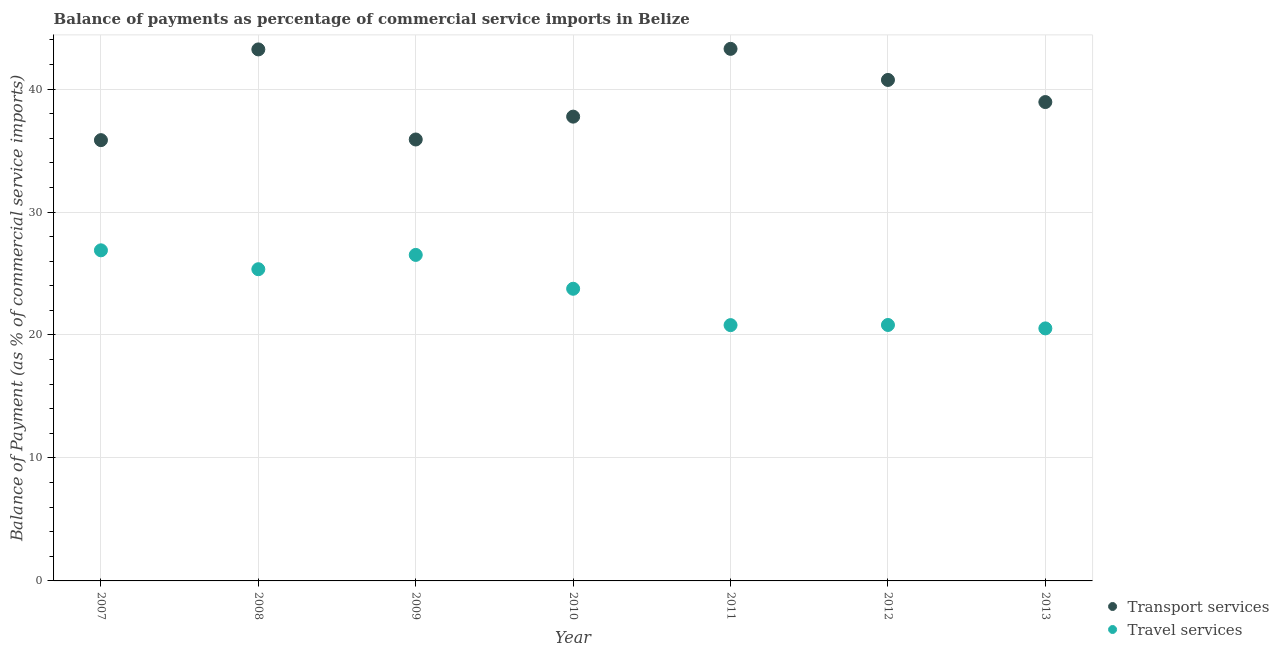Is the number of dotlines equal to the number of legend labels?
Your answer should be very brief. Yes. What is the balance of payments of travel services in 2011?
Make the answer very short. 20.8. Across all years, what is the maximum balance of payments of transport services?
Provide a short and direct response. 43.27. Across all years, what is the minimum balance of payments of transport services?
Make the answer very short. 35.85. In which year was the balance of payments of travel services maximum?
Your answer should be very brief. 2007. In which year was the balance of payments of transport services minimum?
Your answer should be very brief. 2007. What is the total balance of payments of transport services in the graph?
Provide a short and direct response. 275.69. What is the difference between the balance of payments of transport services in 2009 and that in 2013?
Your response must be concise. -3.04. What is the difference between the balance of payments of transport services in 2010 and the balance of payments of travel services in 2012?
Your answer should be very brief. 16.94. What is the average balance of payments of transport services per year?
Your answer should be compact. 39.38. In the year 2007, what is the difference between the balance of payments of travel services and balance of payments of transport services?
Give a very brief answer. -8.96. What is the ratio of the balance of payments of transport services in 2008 to that in 2011?
Ensure brevity in your answer.  1. Is the difference between the balance of payments of travel services in 2009 and 2011 greater than the difference between the balance of payments of transport services in 2009 and 2011?
Your answer should be very brief. Yes. What is the difference between the highest and the second highest balance of payments of travel services?
Keep it short and to the point. 0.37. What is the difference between the highest and the lowest balance of payments of transport services?
Ensure brevity in your answer.  7.42. Is the balance of payments of transport services strictly less than the balance of payments of travel services over the years?
Your answer should be compact. No. How many dotlines are there?
Your response must be concise. 2. How many years are there in the graph?
Offer a terse response. 7. Does the graph contain any zero values?
Make the answer very short. No. How many legend labels are there?
Make the answer very short. 2. What is the title of the graph?
Provide a short and direct response. Balance of payments as percentage of commercial service imports in Belize. What is the label or title of the X-axis?
Your response must be concise. Year. What is the label or title of the Y-axis?
Ensure brevity in your answer.  Balance of Payment (as % of commercial service imports). What is the Balance of Payment (as % of commercial service imports) in Transport services in 2007?
Your response must be concise. 35.85. What is the Balance of Payment (as % of commercial service imports) in Travel services in 2007?
Provide a succinct answer. 26.89. What is the Balance of Payment (as % of commercial service imports) of Transport services in 2008?
Provide a short and direct response. 43.23. What is the Balance of Payment (as % of commercial service imports) in Travel services in 2008?
Provide a short and direct response. 25.35. What is the Balance of Payment (as % of commercial service imports) in Transport services in 2009?
Offer a terse response. 35.9. What is the Balance of Payment (as % of commercial service imports) in Travel services in 2009?
Provide a short and direct response. 26.51. What is the Balance of Payment (as % of commercial service imports) of Transport services in 2010?
Your answer should be compact. 37.76. What is the Balance of Payment (as % of commercial service imports) in Travel services in 2010?
Keep it short and to the point. 23.76. What is the Balance of Payment (as % of commercial service imports) in Transport services in 2011?
Your answer should be very brief. 43.27. What is the Balance of Payment (as % of commercial service imports) of Travel services in 2011?
Provide a short and direct response. 20.8. What is the Balance of Payment (as % of commercial service imports) of Transport services in 2012?
Keep it short and to the point. 40.74. What is the Balance of Payment (as % of commercial service imports) in Travel services in 2012?
Offer a very short reply. 20.82. What is the Balance of Payment (as % of commercial service imports) of Transport services in 2013?
Provide a short and direct response. 38.94. What is the Balance of Payment (as % of commercial service imports) of Travel services in 2013?
Give a very brief answer. 20.54. Across all years, what is the maximum Balance of Payment (as % of commercial service imports) of Transport services?
Make the answer very short. 43.27. Across all years, what is the maximum Balance of Payment (as % of commercial service imports) of Travel services?
Offer a terse response. 26.89. Across all years, what is the minimum Balance of Payment (as % of commercial service imports) in Transport services?
Your answer should be very brief. 35.85. Across all years, what is the minimum Balance of Payment (as % of commercial service imports) in Travel services?
Ensure brevity in your answer.  20.54. What is the total Balance of Payment (as % of commercial service imports) in Transport services in the graph?
Keep it short and to the point. 275.69. What is the total Balance of Payment (as % of commercial service imports) of Travel services in the graph?
Give a very brief answer. 164.66. What is the difference between the Balance of Payment (as % of commercial service imports) in Transport services in 2007 and that in 2008?
Ensure brevity in your answer.  -7.38. What is the difference between the Balance of Payment (as % of commercial service imports) of Travel services in 2007 and that in 2008?
Provide a succinct answer. 1.54. What is the difference between the Balance of Payment (as % of commercial service imports) in Transport services in 2007 and that in 2009?
Keep it short and to the point. -0.05. What is the difference between the Balance of Payment (as % of commercial service imports) in Travel services in 2007 and that in 2009?
Your response must be concise. 0.37. What is the difference between the Balance of Payment (as % of commercial service imports) of Transport services in 2007 and that in 2010?
Your answer should be compact. -1.91. What is the difference between the Balance of Payment (as % of commercial service imports) of Travel services in 2007 and that in 2010?
Offer a terse response. 3.13. What is the difference between the Balance of Payment (as % of commercial service imports) in Transport services in 2007 and that in 2011?
Ensure brevity in your answer.  -7.42. What is the difference between the Balance of Payment (as % of commercial service imports) of Travel services in 2007 and that in 2011?
Provide a succinct answer. 6.08. What is the difference between the Balance of Payment (as % of commercial service imports) of Transport services in 2007 and that in 2012?
Keep it short and to the point. -4.9. What is the difference between the Balance of Payment (as % of commercial service imports) of Travel services in 2007 and that in 2012?
Your answer should be compact. 6.07. What is the difference between the Balance of Payment (as % of commercial service imports) of Transport services in 2007 and that in 2013?
Provide a short and direct response. -3.1. What is the difference between the Balance of Payment (as % of commercial service imports) of Travel services in 2007 and that in 2013?
Ensure brevity in your answer.  6.35. What is the difference between the Balance of Payment (as % of commercial service imports) of Transport services in 2008 and that in 2009?
Give a very brief answer. 7.33. What is the difference between the Balance of Payment (as % of commercial service imports) of Travel services in 2008 and that in 2009?
Give a very brief answer. -1.16. What is the difference between the Balance of Payment (as % of commercial service imports) in Transport services in 2008 and that in 2010?
Give a very brief answer. 5.47. What is the difference between the Balance of Payment (as % of commercial service imports) in Travel services in 2008 and that in 2010?
Provide a succinct answer. 1.59. What is the difference between the Balance of Payment (as % of commercial service imports) in Transport services in 2008 and that in 2011?
Provide a short and direct response. -0.05. What is the difference between the Balance of Payment (as % of commercial service imports) in Travel services in 2008 and that in 2011?
Make the answer very short. 4.55. What is the difference between the Balance of Payment (as % of commercial service imports) in Transport services in 2008 and that in 2012?
Provide a succinct answer. 2.48. What is the difference between the Balance of Payment (as % of commercial service imports) in Travel services in 2008 and that in 2012?
Provide a succinct answer. 4.53. What is the difference between the Balance of Payment (as % of commercial service imports) in Transport services in 2008 and that in 2013?
Provide a short and direct response. 4.28. What is the difference between the Balance of Payment (as % of commercial service imports) of Travel services in 2008 and that in 2013?
Your response must be concise. 4.81. What is the difference between the Balance of Payment (as % of commercial service imports) of Transport services in 2009 and that in 2010?
Your answer should be compact. -1.86. What is the difference between the Balance of Payment (as % of commercial service imports) of Travel services in 2009 and that in 2010?
Your answer should be compact. 2.75. What is the difference between the Balance of Payment (as % of commercial service imports) in Transport services in 2009 and that in 2011?
Your response must be concise. -7.37. What is the difference between the Balance of Payment (as % of commercial service imports) in Travel services in 2009 and that in 2011?
Your response must be concise. 5.71. What is the difference between the Balance of Payment (as % of commercial service imports) of Transport services in 2009 and that in 2012?
Offer a very short reply. -4.84. What is the difference between the Balance of Payment (as % of commercial service imports) in Travel services in 2009 and that in 2012?
Provide a succinct answer. 5.7. What is the difference between the Balance of Payment (as % of commercial service imports) of Transport services in 2009 and that in 2013?
Make the answer very short. -3.04. What is the difference between the Balance of Payment (as % of commercial service imports) in Travel services in 2009 and that in 2013?
Provide a succinct answer. 5.98. What is the difference between the Balance of Payment (as % of commercial service imports) of Transport services in 2010 and that in 2011?
Offer a terse response. -5.51. What is the difference between the Balance of Payment (as % of commercial service imports) of Travel services in 2010 and that in 2011?
Offer a terse response. 2.96. What is the difference between the Balance of Payment (as % of commercial service imports) in Transport services in 2010 and that in 2012?
Your answer should be very brief. -2.98. What is the difference between the Balance of Payment (as % of commercial service imports) in Travel services in 2010 and that in 2012?
Keep it short and to the point. 2.94. What is the difference between the Balance of Payment (as % of commercial service imports) in Transport services in 2010 and that in 2013?
Provide a short and direct response. -1.19. What is the difference between the Balance of Payment (as % of commercial service imports) of Travel services in 2010 and that in 2013?
Ensure brevity in your answer.  3.22. What is the difference between the Balance of Payment (as % of commercial service imports) in Transport services in 2011 and that in 2012?
Your answer should be compact. 2.53. What is the difference between the Balance of Payment (as % of commercial service imports) in Travel services in 2011 and that in 2012?
Offer a terse response. -0.01. What is the difference between the Balance of Payment (as % of commercial service imports) of Transport services in 2011 and that in 2013?
Make the answer very short. 4.33. What is the difference between the Balance of Payment (as % of commercial service imports) of Travel services in 2011 and that in 2013?
Keep it short and to the point. 0.27. What is the difference between the Balance of Payment (as % of commercial service imports) in Transport services in 2012 and that in 2013?
Your answer should be compact. 1.8. What is the difference between the Balance of Payment (as % of commercial service imports) in Travel services in 2012 and that in 2013?
Offer a terse response. 0.28. What is the difference between the Balance of Payment (as % of commercial service imports) in Transport services in 2007 and the Balance of Payment (as % of commercial service imports) in Travel services in 2008?
Offer a terse response. 10.5. What is the difference between the Balance of Payment (as % of commercial service imports) in Transport services in 2007 and the Balance of Payment (as % of commercial service imports) in Travel services in 2009?
Offer a terse response. 9.33. What is the difference between the Balance of Payment (as % of commercial service imports) in Transport services in 2007 and the Balance of Payment (as % of commercial service imports) in Travel services in 2010?
Give a very brief answer. 12.09. What is the difference between the Balance of Payment (as % of commercial service imports) of Transport services in 2007 and the Balance of Payment (as % of commercial service imports) of Travel services in 2011?
Give a very brief answer. 15.04. What is the difference between the Balance of Payment (as % of commercial service imports) of Transport services in 2007 and the Balance of Payment (as % of commercial service imports) of Travel services in 2012?
Your answer should be very brief. 15.03. What is the difference between the Balance of Payment (as % of commercial service imports) of Transport services in 2007 and the Balance of Payment (as % of commercial service imports) of Travel services in 2013?
Your answer should be compact. 15.31. What is the difference between the Balance of Payment (as % of commercial service imports) in Transport services in 2008 and the Balance of Payment (as % of commercial service imports) in Travel services in 2009?
Your answer should be very brief. 16.71. What is the difference between the Balance of Payment (as % of commercial service imports) in Transport services in 2008 and the Balance of Payment (as % of commercial service imports) in Travel services in 2010?
Ensure brevity in your answer.  19.47. What is the difference between the Balance of Payment (as % of commercial service imports) in Transport services in 2008 and the Balance of Payment (as % of commercial service imports) in Travel services in 2011?
Provide a short and direct response. 22.42. What is the difference between the Balance of Payment (as % of commercial service imports) of Transport services in 2008 and the Balance of Payment (as % of commercial service imports) of Travel services in 2012?
Your answer should be very brief. 22.41. What is the difference between the Balance of Payment (as % of commercial service imports) in Transport services in 2008 and the Balance of Payment (as % of commercial service imports) in Travel services in 2013?
Ensure brevity in your answer.  22.69. What is the difference between the Balance of Payment (as % of commercial service imports) of Transport services in 2009 and the Balance of Payment (as % of commercial service imports) of Travel services in 2010?
Ensure brevity in your answer.  12.14. What is the difference between the Balance of Payment (as % of commercial service imports) in Transport services in 2009 and the Balance of Payment (as % of commercial service imports) in Travel services in 2011?
Offer a terse response. 15.1. What is the difference between the Balance of Payment (as % of commercial service imports) in Transport services in 2009 and the Balance of Payment (as % of commercial service imports) in Travel services in 2012?
Provide a short and direct response. 15.09. What is the difference between the Balance of Payment (as % of commercial service imports) of Transport services in 2009 and the Balance of Payment (as % of commercial service imports) of Travel services in 2013?
Ensure brevity in your answer.  15.36. What is the difference between the Balance of Payment (as % of commercial service imports) in Transport services in 2010 and the Balance of Payment (as % of commercial service imports) in Travel services in 2011?
Make the answer very short. 16.96. What is the difference between the Balance of Payment (as % of commercial service imports) of Transport services in 2010 and the Balance of Payment (as % of commercial service imports) of Travel services in 2012?
Your answer should be compact. 16.94. What is the difference between the Balance of Payment (as % of commercial service imports) of Transport services in 2010 and the Balance of Payment (as % of commercial service imports) of Travel services in 2013?
Provide a succinct answer. 17.22. What is the difference between the Balance of Payment (as % of commercial service imports) of Transport services in 2011 and the Balance of Payment (as % of commercial service imports) of Travel services in 2012?
Offer a very short reply. 22.46. What is the difference between the Balance of Payment (as % of commercial service imports) in Transport services in 2011 and the Balance of Payment (as % of commercial service imports) in Travel services in 2013?
Your response must be concise. 22.73. What is the difference between the Balance of Payment (as % of commercial service imports) in Transport services in 2012 and the Balance of Payment (as % of commercial service imports) in Travel services in 2013?
Offer a terse response. 20.21. What is the average Balance of Payment (as % of commercial service imports) in Transport services per year?
Your answer should be very brief. 39.38. What is the average Balance of Payment (as % of commercial service imports) of Travel services per year?
Offer a very short reply. 23.52. In the year 2007, what is the difference between the Balance of Payment (as % of commercial service imports) in Transport services and Balance of Payment (as % of commercial service imports) in Travel services?
Keep it short and to the point. 8.96. In the year 2008, what is the difference between the Balance of Payment (as % of commercial service imports) in Transport services and Balance of Payment (as % of commercial service imports) in Travel services?
Provide a succinct answer. 17.88. In the year 2009, what is the difference between the Balance of Payment (as % of commercial service imports) in Transport services and Balance of Payment (as % of commercial service imports) in Travel services?
Your answer should be very brief. 9.39. In the year 2010, what is the difference between the Balance of Payment (as % of commercial service imports) of Transport services and Balance of Payment (as % of commercial service imports) of Travel services?
Provide a succinct answer. 14. In the year 2011, what is the difference between the Balance of Payment (as % of commercial service imports) of Transport services and Balance of Payment (as % of commercial service imports) of Travel services?
Provide a succinct answer. 22.47. In the year 2012, what is the difference between the Balance of Payment (as % of commercial service imports) of Transport services and Balance of Payment (as % of commercial service imports) of Travel services?
Provide a short and direct response. 19.93. In the year 2013, what is the difference between the Balance of Payment (as % of commercial service imports) in Transport services and Balance of Payment (as % of commercial service imports) in Travel services?
Your response must be concise. 18.41. What is the ratio of the Balance of Payment (as % of commercial service imports) in Transport services in 2007 to that in 2008?
Provide a succinct answer. 0.83. What is the ratio of the Balance of Payment (as % of commercial service imports) in Travel services in 2007 to that in 2008?
Make the answer very short. 1.06. What is the ratio of the Balance of Payment (as % of commercial service imports) in Transport services in 2007 to that in 2009?
Give a very brief answer. 1. What is the ratio of the Balance of Payment (as % of commercial service imports) of Travel services in 2007 to that in 2009?
Give a very brief answer. 1.01. What is the ratio of the Balance of Payment (as % of commercial service imports) in Transport services in 2007 to that in 2010?
Offer a terse response. 0.95. What is the ratio of the Balance of Payment (as % of commercial service imports) in Travel services in 2007 to that in 2010?
Provide a short and direct response. 1.13. What is the ratio of the Balance of Payment (as % of commercial service imports) of Transport services in 2007 to that in 2011?
Your response must be concise. 0.83. What is the ratio of the Balance of Payment (as % of commercial service imports) of Travel services in 2007 to that in 2011?
Provide a short and direct response. 1.29. What is the ratio of the Balance of Payment (as % of commercial service imports) of Transport services in 2007 to that in 2012?
Your answer should be compact. 0.88. What is the ratio of the Balance of Payment (as % of commercial service imports) in Travel services in 2007 to that in 2012?
Ensure brevity in your answer.  1.29. What is the ratio of the Balance of Payment (as % of commercial service imports) of Transport services in 2007 to that in 2013?
Make the answer very short. 0.92. What is the ratio of the Balance of Payment (as % of commercial service imports) in Travel services in 2007 to that in 2013?
Give a very brief answer. 1.31. What is the ratio of the Balance of Payment (as % of commercial service imports) of Transport services in 2008 to that in 2009?
Your answer should be compact. 1.2. What is the ratio of the Balance of Payment (as % of commercial service imports) in Travel services in 2008 to that in 2009?
Make the answer very short. 0.96. What is the ratio of the Balance of Payment (as % of commercial service imports) in Transport services in 2008 to that in 2010?
Ensure brevity in your answer.  1.14. What is the ratio of the Balance of Payment (as % of commercial service imports) in Travel services in 2008 to that in 2010?
Your answer should be very brief. 1.07. What is the ratio of the Balance of Payment (as % of commercial service imports) in Travel services in 2008 to that in 2011?
Ensure brevity in your answer.  1.22. What is the ratio of the Balance of Payment (as % of commercial service imports) of Transport services in 2008 to that in 2012?
Offer a terse response. 1.06. What is the ratio of the Balance of Payment (as % of commercial service imports) of Travel services in 2008 to that in 2012?
Your answer should be very brief. 1.22. What is the ratio of the Balance of Payment (as % of commercial service imports) in Transport services in 2008 to that in 2013?
Your response must be concise. 1.11. What is the ratio of the Balance of Payment (as % of commercial service imports) in Travel services in 2008 to that in 2013?
Keep it short and to the point. 1.23. What is the ratio of the Balance of Payment (as % of commercial service imports) of Transport services in 2009 to that in 2010?
Your answer should be very brief. 0.95. What is the ratio of the Balance of Payment (as % of commercial service imports) in Travel services in 2009 to that in 2010?
Keep it short and to the point. 1.12. What is the ratio of the Balance of Payment (as % of commercial service imports) in Transport services in 2009 to that in 2011?
Give a very brief answer. 0.83. What is the ratio of the Balance of Payment (as % of commercial service imports) of Travel services in 2009 to that in 2011?
Give a very brief answer. 1.27. What is the ratio of the Balance of Payment (as % of commercial service imports) of Transport services in 2009 to that in 2012?
Make the answer very short. 0.88. What is the ratio of the Balance of Payment (as % of commercial service imports) of Travel services in 2009 to that in 2012?
Ensure brevity in your answer.  1.27. What is the ratio of the Balance of Payment (as % of commercial service imports) in Transport services in 2009 to that in 2013?
Offer a very short reply. 0.92. What is the ratio of the Balance of Payment (as % of commercial service imports) of Travel services in 2009 to that in 2013?
Provide a succinct answer. 1.29. What is the ratio of the Balance of Payment (as % of commercial service imports) in Transport services in 2010 to that in 2011?
Provide a succinct answer. 0.87. What is the ratio of the Balance of Payment (as % of commercial service imports) of Travel services in 2010 to that in 2011?
Provide a succinct answer. 1.14. What is the ratio of the Balance of Payment (as % of commercial service imports) of Transport services in 2010 to that in 2012?
Offer a very short reply. 0.93. What is the ratio of the Balance of Payment (as % of commercial service imports) in Travel services in 2010 to that in 2012?
Offer a terse response. 1.14. What is the ratio of the Balance of Payment (as % of commercial service imports) in Transport services in 2010 to that in 2013?
Offer a terse response. 0.97. What is the ratio of the Balance of Payment (as % of commercial service imports) of Travel services in 2010 to that in 2013?
Give a very brief answer. 1.16. What is the ratio of the Balance of Payment (as % of commercial service imports) in Transport services in 2011 to that in 2012?
Make the answer very short. 1.06. What is the ratio of the Balance of Payment (as % of commercial service imports) of Travel services in 2011 to that in 2012?
Your response must be concise. 1. What is the ratio of the Balance of Payment (as % of commercial service imports) in Transport services in 2011 to that in 2013?
Ensure brevity in your answer.  1.11. What is the ratio of the Balance of Payment (as % of commercial service imports) of Travel services in 2011 to that in 2013?
Offer a terse response. 1.01. What is the ratio of the Balance of Payment (as % of commercial service imports) of Transport services in 2012 to that in 2013?
Your answer should be compact. 1.05. What is the ratio of the Balance of Payment (as % of commercial service imports) in Travel services in 2012 to that in 2013?
Keep it short and to the point. 1.01. What is the difference between the highest and the second highest Balance of Payment (as % of commercial service imports) of Transport services?
Ensure brevity in your answer.  0.05. What is the difference between the highest and the second highest Balance of Payment (as % of commercial service imports) of Travel services?
Provide a short and direct response. 0.37. What is the difference between the highest and the lowest Balance of Payment (as % of commercial service imports) in Transport services?
Offer a terse response. 7.42. What is the difference between the highest and the lowest Balance of Payment (as % of commercial service imports) of Travel services?
Provide a short and direct response. 6.35. 